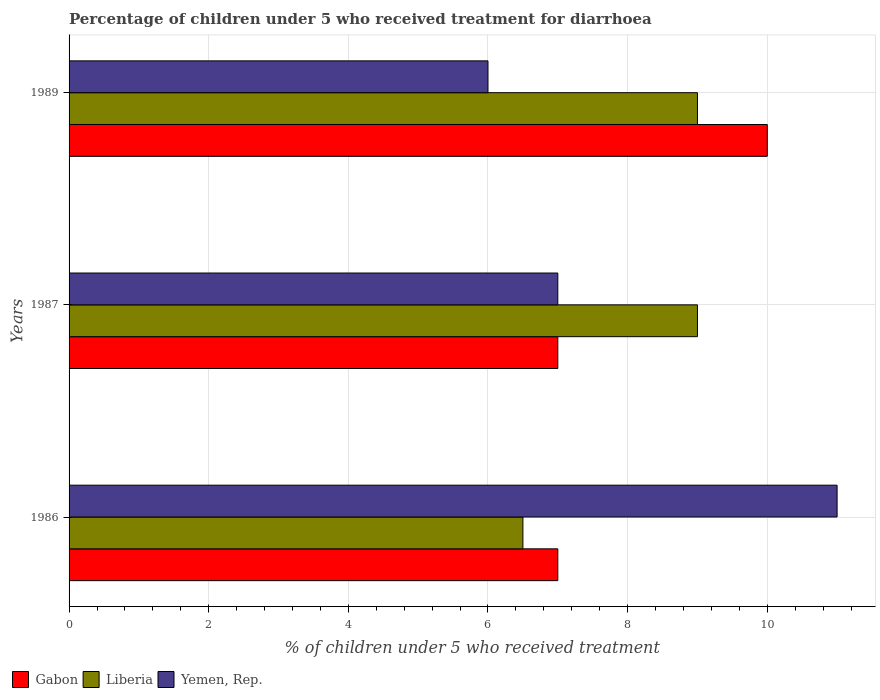How many different coloured bars are there?
Offer a terse response. 3. Are the number of bars per tick equal to the number of legend labels?
Provide a short and direct response. Yes. Are the number of bars on each tick of the Y-axis equal?
Your response must be concise. Yes. How many bars are there on the 3rd tick from the top?
Give a very brief answer. 3. How many bars are there on the 2nd tick from the bottom?
Your answer should be very brief. 3. Across all years, what is the maximum percentage of children who received treatment for diarrhoea  in Liberia?
Make the answer very short. 9. In which year was the percentage of children who received treatment for diarrhoea  in Gabon maximum?
Make the answer very short. 1989. In which year was the percentage of children who received treatment for diarrhoea  in Gabon minimum?
Offer a very short reply. 1986. What is the total percentage of children who received treatment for diarrhoea  in Yemen, Rep. in the graph?
Your response must be concise. 24. What is the average percentage of children who received treatment for diarrhoea  in Gabon per year?
Keep it short and to the point. 8. What is the ratio of the percentage of children who received treatment for diarrhoea  in Liberia in 1986 to that in 1989?
Ensure brevity in your answer.  0.72. Is the percentage of children who received treatment for diarrhoea  in Yemen, Rep. in 1987 less than that in 1989?
Provide a short and direct response. No. What is the difference between the highest and the second highest percentage of children who received treatment for diarrhoea  in Gabon?
Offer a terse response. 3. In how many years, is the percentage of children who received treatment for diarrhoea  in Gabon greater than the average percentage of children who received treatment for diarrhoea  in Gabon taken over all years?
Your response must be concise. 1. What does the 3rd bar from the top in 1989 represents?
Your answer should be very brief. Gabon. What does the 3rd bar from the bottom in 1986 represents?
Ensure brevity in your answer.  Yemen, Rep. Is it the case that in every year, the sum of the percentage of children who received treatment for diarrhoea  in Gabon and percentage of children who received treatment for diarrhoea  in Yemen, Rep. is greater than the percentage of children who received treatment for diarrhoea  in Liberia?
Make the answer very short. Yes. How many bars are there?
Your response must be concise. 9. What is the difference between two consecutive major ticks on the X-axis?
Provide a short and direct response. 2. Are the values on the major ticks of X-axis written in scientific E-notation?
Make the answer very short. No. Does the graph contain any zero values?
Keep it short and to the point. No. Does the graph contain grids?
Keep it short and to the point. Yes. How many legend labels are there?
Your answer should be compact. 3. What is the title of the graph?
Offer a terse response. Percentage of children under 5 who received treatment for diarrhoea. Does "Other small states" appear as one of the legend labels in the graph?
Make the answer very short. No. What is the label or title of the X-axis?
Your answer should be compact. % of children under 5 who received treatment. What is the label or title of the Y-axis?
Your answer should be very brief. Years. What is the % of children under 5 who received treatment in Gabon in 1986?
Keep it short and to the point. 7. What is the % of children under 5 who received treatment in Liberia in 1986?
Offer a terse response. 6.5. What is the % of children under 5 who received treatment in Yemen, Rep. in 1986?
Ensure brevity in your answer.  11. What is the % of children under 5 who received treatment in Liberia in 1987?
Ensure brevity in your answer.  9. What is the % of children under 5 who received treatment of Yemen, Rep. in 1987?
Your response must be concise. 7. What is the % of children under 5 who received treatment in Gabon in 1989?
Your answer should be very brief. 10. Across all years, what is the maximum % of children under 5 who received treatment in Gabon?
Offer a terse response. 10. Across all years, what is the maximum % of children under 5 who received treatment of Liberia?
Provide a succinct answer. 9. Across all years, what is the minimum % of children under 5 who received treatment in Gabon?
Make the answer very short. 7. Across all years, what is the minimum % of children under 5 who received treatment of Liberia?
Keep it short and to the point. 6.5. What is the total % of children under 5 who received treatment of Gabon in the graph?
Give a very brief answer. 24. What is the total % of children under 5 who received treatment of Liberia in the graph?
Make the answer very short. 24.5. What is the total % of children under 5 who received treatment in Yemen, Rep. in the graph?
Your answer should be very brief. 24. What is the difference between the % of children under 5 who received treatment in Gabon in 1986 and that in 1987?
Give a very brief answer. 0. What is the difference between the % of children under 5 who received treatment of Gabon in 1986 and that in 1989?
Your answer should be very brief. -3. What is the difference between the % of children under 5 who received treatment in Gabon in 1986 and the % of children under 5 who received treatment in Yemen, Rep. in 1987?
Keep it short and to the point. 0. What is the difference between the % of children under 5 who received treatment in Liberia in 1986 and the % of children under 5 who received treatment in Yemen, Rep. in 1987?
Ensure brevity in your answer.  -0.5. What is the difference between the % of children under 5 who received treatment of Gabon in 1986 and the % of children under 5 who received treatment of Yemen, Rep. in 1989?
Keep it short and to the point. 1. What is the difference between the % of children under 5 who received treatment in Liberia in 1986 and the % of children under 5 who received treatment in Yemen, Rep. in 1989?
Your answer should be compact. 0.5. What is the difference between the % of children under 5 who received treatment of Gabon in 1987 and the % of children under 5 who received treatment of Yemen, Rep. in 1989?
Your response must be concise. 1. What is the average % of children under 5 who received treatment of Liberia per year?
Keep it short and to the point. 8.17. In the year 1986, what is the difference between the % of children under 5 who received treatment in Gabon and % of children under 5 who received treatment in Liberia?
Offer a very short reply. 0.5. In the year 1987, what is the difference between the % of children under 5 who received treatment in Liberia and % of children under 5 who received treatment in Yemen, Rep.?
Offer a very short reply. 2. In the year 1989, what is the difference between the % of children under 5 who received treatment of Gabon and % of children under 5 who received treatment of Liberia?
Your response must be concise. 1. In the year 1989, what is the difference between the % of children under 5 who received treatment of Liberia and % of children under 5 who received treatment of Yemen, Rep.?
Provide a succinct answer. 3. What is the ratio of the % of children under 5 who received treatment in Liberia in 1986 to that in 1987?
Your answer should be very brief. 0.72. What is the ratio of the % of children under 5 who received treatment of Yemen, Rep. in 1986 to that in 1987?
Your response must be concise. 1.57. What is the ratio of the % of children under 5 who received treatment of Liberia in 1986 to that in 1989?
Keep it short and to the point. 0.72. What is the ratio of the % of children under 5 who received treatment in Yemen, Rep. in 1986 to that in 1989?
Keep it short and to the point. 1.83. What is the ratio of the % of children under 5 who received treatment of Gabon in 1987 to that in 1989?
Ensure brevity in your answer.  0.7. What is the difference between the highest and the lowest % of children under 5 who received treatment of Gabon?
Keep it short and to the point. 3. What is the difference between the highest and the lowest % of children under 5 who received treatment in Yemen, Rep.?
Your response must be concise. 5. 